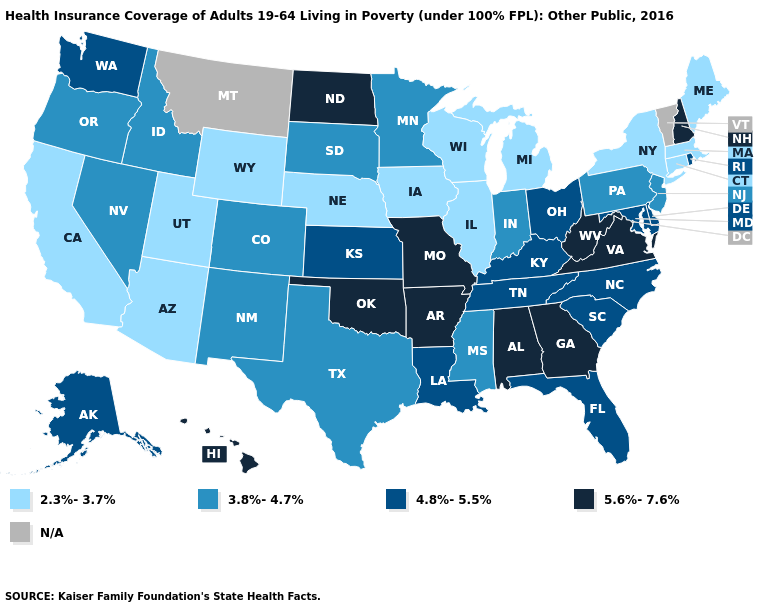What is the value of Wisconsin?
Short answer required. 2.3%-3.7%. Does Hawaii have the highest value in the West?
Quick response, please. Yes. What is the value of North Carolina?
Give a very brief answer. 4.8%-5.5%. Among the states that border South Dakota , does Nebraska have the highest value?
Quick response, please. No. What is the value of Utah?
Be succinct. 2.3%-3.7%. Name the states that have a value in the range 2.3%-3.7%?
Quick response, please. Arizona, California, Connecticut, Illinois, Iowa, Maine, Massachusetts, Michigan, Nebraska, New York, Utah, Wisconsin, Wyoming. What is the value of Alaska?
Give a very brief answer. 4.8%-5.5%. Which states have the highest value in the USA?
Answer briefly. Alabama, Arkansas, Georgia, Hawaii, Missouri, New Hampshire, North Dakota, Oklahoma, Virginia, West Virginia. What is the value of Georgia?
Be succinct. 5.6%-7.6%. Does Hawaii have the lowest value in the USA?
Concise answer only. No. Which states hav the highest value in the West?
Answer briefly. Hawaii. Name the states that have a value in the range 3.8%-4.7%?
Concise answer only. Colorado, Idaho, Indiana, Minnesota, Mississippi, Nevada, New Jersey, New Mexico, Oregon, Pennsylvania, South Dakota, Texas. Name the states that have a value in the range 4.8%-5.5%?
Concise answer only. Alaska, Delaware, Florida, Kansas, Kentucky, Louisiana, Maryland, North Carolina, Ohio, Rhode Island, South Carolina, Tennessee, Washington. Among the states that border Illinois , does Indiana have the lowest value?
Write a very short answer. No. 